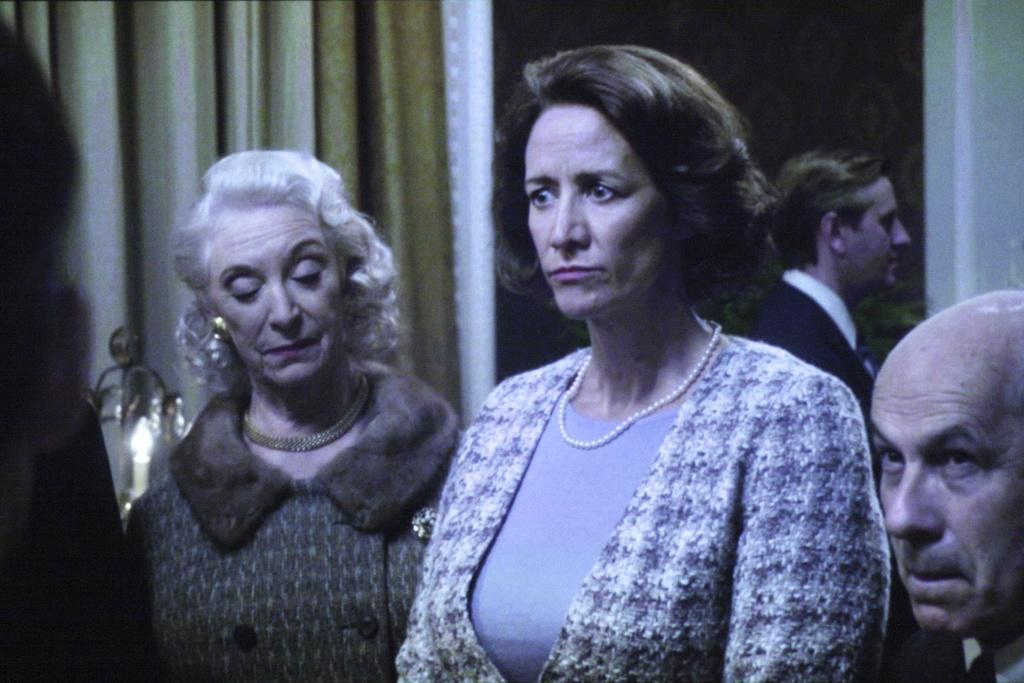How many people are in the image? There is a group of people in the image, but the exact number cannot be determined from the provided facts. What is the purpose of the curtain in the image? The purpose of the curtain is not clear from the provided facts, but it is visible in the image. What is the candle used for in the image? The purpose of the candle is not clear from the provided facts, but it is visible in the image. Can you confirm the presence of a door in the image? The presence of a door is mentioned as a possibility, but it cannot be confirmed from the provided facts. What type of zebra is visible in the image? There is no zebra present in the image. How does the brother interact with the group of people in the image? There is no mention of a brother in the provided facts, so we cannot answer this question. 